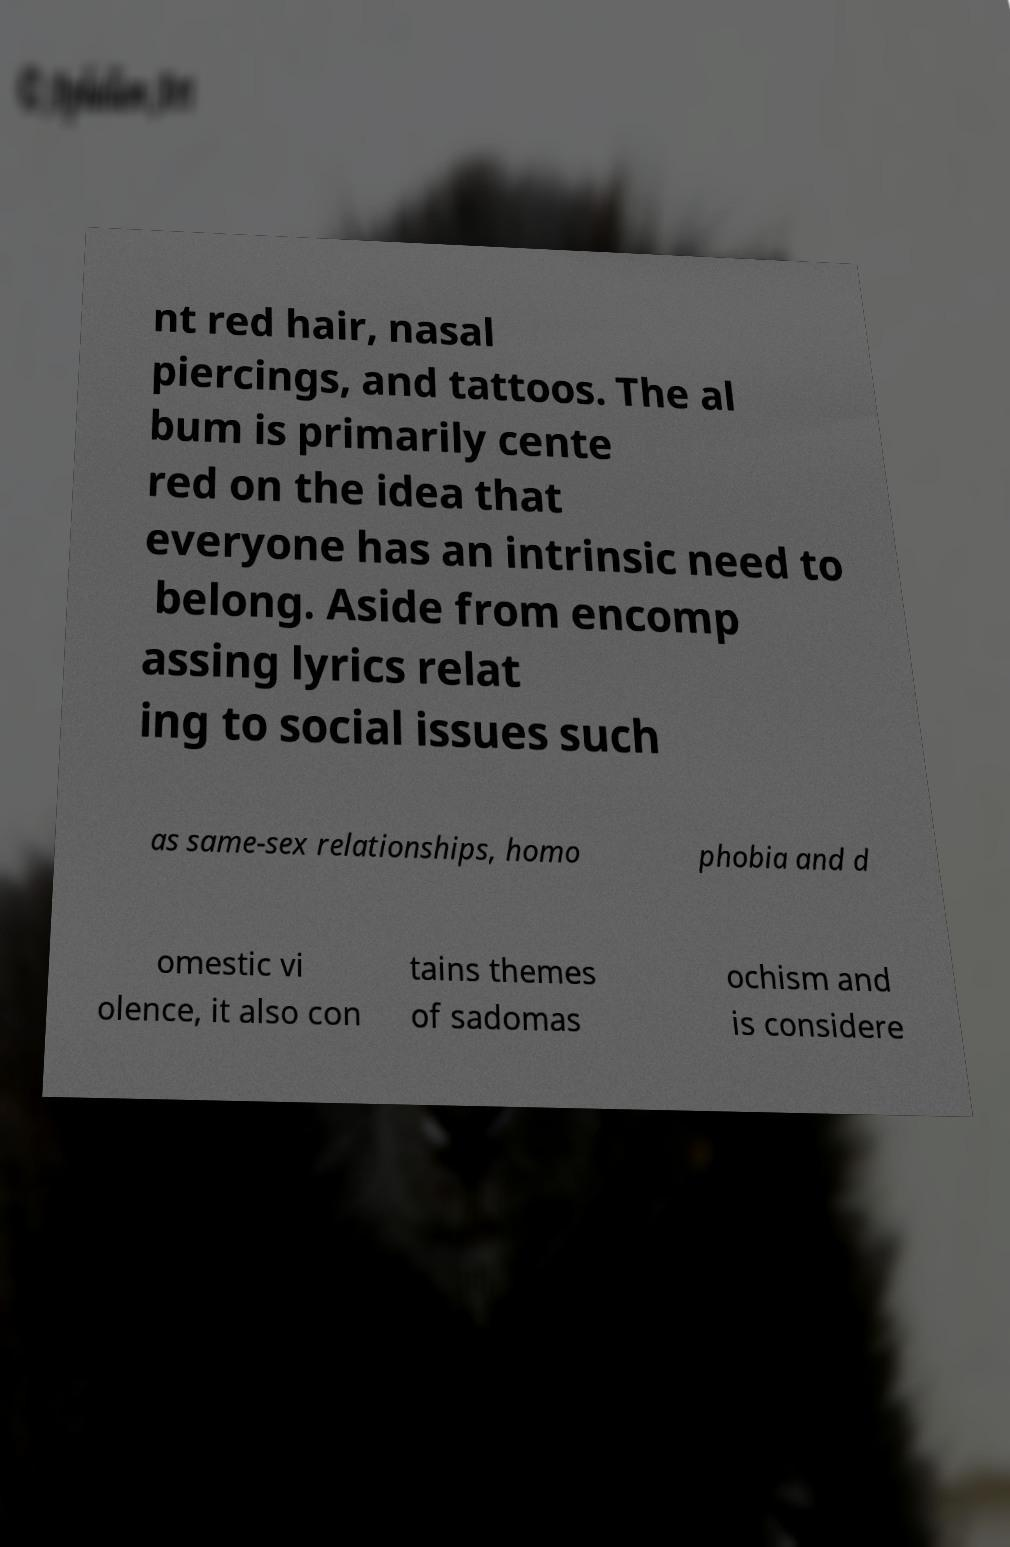Please read and relay the text visible in this image. What does it say? nt red hair, nasal piercings, and tattoos. The al bum is primarily cente red on the idea that everyone has an intrinsic need to belong. Aside from encomp assing lyrics relat ing to social issues such as same-sex relationships, homo phobia and d omestic vi olence, it also con tains themes of sadomas ochism and is considere 